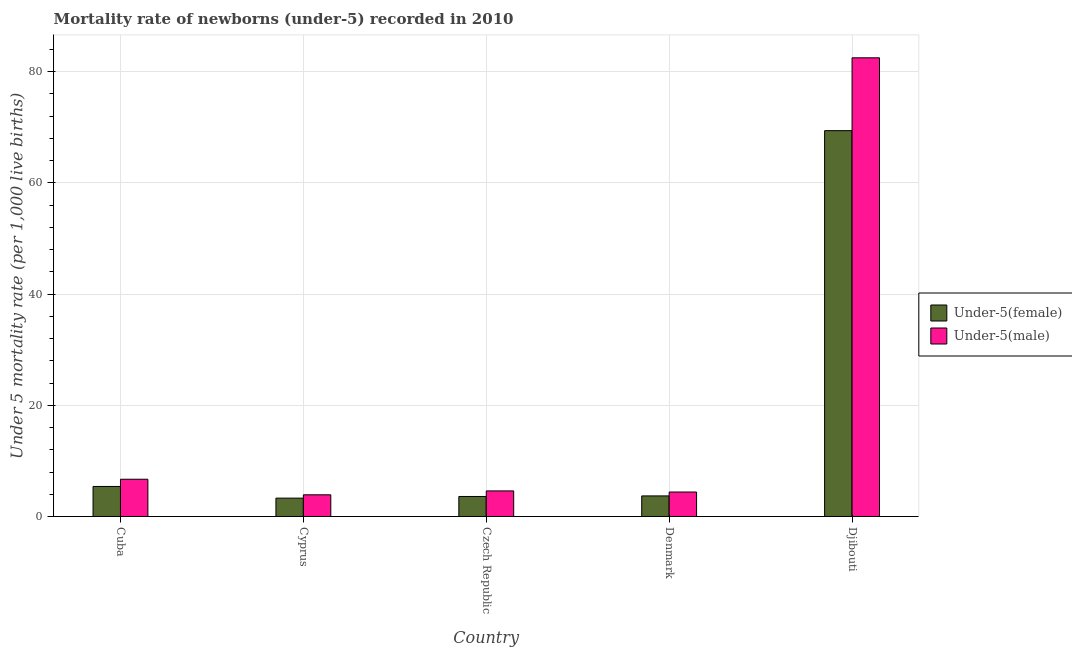What is the label of the 2nd group of bars from the left?
Offer a terse response. Cyprus. In how many cases, is the number of bars for a given country not equal to the number of legend labels?
Offer a very short reply. 0. Across all countries, what is the maximum under-5 female mortality rate?
Provide a short and direct response. 69.4. Across all countries, what is the minimum under-5 female mortality rate?
Ensure brevity in your answer.  3.3. In which country was the under-5 male mortality rate maximum?
Make the answer very short. Djibouti. In which country was the under-5 female mortality rate minimum?
Make the answer very short. Cyprus. What is the total under-5 female mortality rate in the graph?
Your answer should be compact. 85.4. What is the difference between the under-5 male mortality rate in Cyprus and that in Djibouti?
Offer a very short reply. -78.6. What is the difference between the under-5 male mortality rate in Cuba and the under-5 female mortality rate in Djibouti?
Keep it short and to the point. -62.7. What is the average under-5 female mortality rate per country?
Your answer should be very brief. 17.08. What is the difference between the under-5 female mortality rate and under-5 male mortality rate in Cyprus?
Your response must be concise. -0.6. In how many countries, is the under-5 female mortality rate greater than 36 ?
Your answer should be very brief. 1. What is the ratio of the under-5 female mortality rate in Czech Republic to that in Djibouti?
Your response must be concise. 0.05. Is the under-5 male mortality rate in Cyprus less than that in Denmark?
Keep it short and to the point. Yes. Is the difference between the under-5 female mortality rate in Cyprus and Czech Republic greater than the difference between the under-5 male mortality rate in Cyprus and Czech Republic?
Your answer should be compact. Yes. What is the difference between the highest and the second highest under-5 male mortality rate?
Provide a succinct answer. 75.8. What is the difference between the highest and the lowest under-5 male mortality rate?
Your answer should be compact. 78.6. In how many countries, is the under-5 female mortality rate greater than the average under-5 female mortality rate taken over all countries?
Your response must be concise. 1. Is the sum of the under-5 female mortality rate in Czech Republic and Denmark greater than the maximum under-5 male mortality rate across all countries?
Provide a short and direct response. No. What does the 2nd bar from the left in Denmark represents?
Your answer should be very brief. Under-5(male). What does the 2nd bar from the right in Cyprus represents?
Offer a terse response. Under-5(female). How many countries are there in the graph?
Provide a short and direct response. 5. Are the values on the major ticks of Y-axis written in scientific E-notation?
Make the answer very short. No. Does the graph contain any zero values?
Your answer should be very brief. No. Where does the legend appear in the graph?
Your answer should be very brief. Center right. How are the legend labels stacked?
Make the answer very short. Vertical. What is the title of the graph?
Your answer should be compact. Mortality rate of newborns (under-5) recorded in 2010. Does "Male labourers" appear as one of the legend labels in the graph?
Your answer should be very brief. No. What is the label or title of the X-axis?
Give a very brief answer. Country. What is the label or title of the Y-axis?
Your answer should be very brief. Under 5 mortality rate (per 1,0 live births). What is the Under 5 mortality rate (per 1,000 live births) of Under-5(male) in Cuba?
Keep it short and to the point. 6.7. What is the Under 5 mortality rate (per 1,000 live births) of Under-5(female) in Djibouti?
Offer a very short reply. 69.4. What is the Under 5 mortality rate (per 1,000 live births) in Under-5(male) in Djibouti?
Provide a succinct answer. 82.5. Across all countries, what is the maximum Under 5 mortality rate (per 1,000 live births) of Under-5(female)?
Your response must be concise. 69.4. Across all countries, what is the maximum Under 5 mortality rate (per 1,000 live births) of Under-5(male)?
Offer a very short reply. 82.5. Across all countries, what is the minimum Under 5 mortality rate (per 1,000 live births) in Under-5(male)?
Your answer should be compact. 3.9. What is the total Under 5 mortality rate (per 1,000 live births) of Under-5(female) in the graph?
Your answer should be compact. 85.4. What is the total Under 5 mortality rate (per 1,000 live births) of Under-5(male) in the graph?
Your answer should be compact. 102.1. What is the difference between the Under 5 mortality rate (per 1,000 live births) of Under-5(female) in Cuba and that in Czech Republic?
Provide a succinct answer. 1.8. What is the difference between the Under 5 mortality rate (per 1,000 live births) of Under-5(male) in Cuba and that in Czech Republic?
Ensure brevity in your answer.  2.1. What is the difference between the Under 5 mortality rate (per 1,000 live births) in Under-5(female) in Cuba and that in Denmark?
Provide a succinct answer. 1.7. What is the difference between the Under 5 mortality rate (per 1,000 live births) of Under-5(female) in Cuba and that in Djibouti?
Your response must be concise. -64. What is the difference between the Under 5 mortality rate (per 1,000 live births) in Under-5(male) in Cuba and that in Djibouti?
Give a very brief answer. -75.8. What is the difference between the Under 5 mortality rate (per 1,000 live births) of Under-5(female) in Cyprus and that in Czech Republic?
Provide a short and direct response. -0.3. What is the difference between the Under 5 mortality rate (per 1,000 live births) in Under-5(male) in Cyprus and that in Czech Republic?
Your response must be concise. -0.7. What is the difference between the Under 5 mortality rate (per 1,000 live births) of Under-5(male) in Cyprus and that in Denmark?
Your answer should be very brief. -0.5. What is the difference between the Under 5 mortality rate (per 1,000 live births) in Under-5(female) in Cyprus and that in Djibouti?
Provide a short and direct response. -66.1. What is the difference between the Under 5 mortality rate (per 1,000 live births) in Under-5(male) in Cyprus and that in Djibouti?
Ensure brevity in your answer.  -78.6. What is the difference between the Under 5 mortality rate (per 1,000 live births) in Under-5(female) in Czech Republic and that in Djibouti?
Provide a succinct answer. -65.8. What is the difference between the Under 5 mortality rate (per 1,000 live births) in Under-5(male) in Czech Republic and that in Djibouti?
Your response must be concise. -77.9. What is the difference between the Under 5 mortality rate (per 1,000 live births) in Under-5(female) in Denmark and that in Djibouti?
Give a very brief answer. -65.7. What is the difference between the Under 5 mortality rate (per 1,000 live births) in Under-5(male) in Denmark and that in Djibouti?
Provide a succinct answer. -78.1. What is the difference between the Under 5 mortality rate (per 1,000 live births) in Under-5(female) in Cuba and the Under 5 mortality rate (per 1,000 live births) in Under-5(male) in Cyprus?
Offer a terse response. 1.5. What is the difference between the Under 5 mortality rate (per 1,000 live births) of Under-5(female) in Cuba and the Under 5 mortality rate (per 1,000 live births) of Under-5(male) in Czech Republic?
Your answer should be compact. 0.8. What is the difference between the Under 5 mortality rate (per 1,000 live births) in Under-5(female) in Cuba and the Under 5 mortality rate (per 1,000 live births) in Under-5(male) in Denmark?
Keep it short and to the point. 1. What is the difference between the Under 5 mortality rate (per 1,000 live births) of Under-5(female) in Cuba and the Under 5 mortality rate (per 1,000 live births) of Under-5(male) in Djibouti?
Keep it short and to the point. -77.1. What is the difference between the Under 5 mortality rate (per 1,000 live births) of Under-5(female) in Cyprus and the Under 5 mortality rate (per 1,000 live births) of Under-5(male) in Czech Republic?
Offer a very short reply. -1.3. What is the difference between the Under 5 mortality rate (per 1,000 live births) in Under-5(female) in Cyprus and the Under 5 mortality rate (per 1,000 live births) in Under-5(male) in Djibouti?
Your answer should be compact. -79.2. What is the difference between the Under 5 mortality rate (per 1,000 live births) of Under-5(female) in Czech Republic and the Under 5 mortality rate (per 1,000 live births) of Under-5(male) in Denmark?
Offer a very short reply. -0.8. What is the difference between the Under 5 mortality rate (per 1,000 live births) in Under-5(female) in Czech Republic and the Under 5 mortality rate (per 1,000 live births) in Under-5(male) in Djibouti?
Provide a succinct answer. -78.9. What is the difference between the Under 5 mortality rate (per 1,000 live births) in Under-5(female) in Denmark and the Under 5 mortality rate (per 1,000 live births) in Under-5(male) in Djibouti?
Your answer should be compact. -78.8. What is the average Under 5 mortality rate (per 1,000 live births) of Under-5(female) per country?
Ensure brevity in your answer.  17.08. What is the average Under 5 mortality rate (per 1,000 live births) in Under-5(male) per country?
Your answer should be compact. 20.42. What is the difference between the Under 5 mortality rate (per 1,000 live births) in Under-5(female) and Under 5 mortality rate (per 1,000 live births) in Under-5(male) in Cuba?
Your answer should be very brief. -1.3. What is the difference between the Under 5 mortality rate (per 1,000 live births) of Under-5(female) and Under 5 mortality rate (per 1,000 live births) of Under-5(male) in Czech Republic?
Provide a short and direct response. -1. What is the ratio of the Under 5 mortality rate (per 1,000 live births) of Under-5(female) in Cuba to that in Cyprus?
Provide a short and direct response. 1.64. What is the ratio of the Under 5 mortality rate (per 1,000 live births) of Under-5(male) in Cuba to that in Cyprus?
Offer a terse response. 1.72. What is the ratio of the Under 5 mortality rate (per 1,000 live births) in Under-5(male) in Cuba to that in Czech Republic?
Your answer should be compact. 1.46. What is the ratio of the Under 5 mortality rate (per 1,000 live births) of Under-5(female) in Cuba to that in Denmark?
Your response must be concise. 1.46. What is the ratio of the Under 5 mortality rate (per 1,000 live births) in Under-5(male) in Cuba to that in Denmark?
Provide a succinct answer. 1.52. What is the ratio of the Under 5 mortality rate (per 1,000 live births) of Under-5(female) in Cuba to that in Djibouti?
Keep it short and to the point. 0.08. What is the ratio of the Under 5 mortality rate (per 1,000 live births) in Under-5(male) in Cuba to that in Djibouti?
Provide a succinct answer. 0.08. What is the ratio of the Under 5 mortality rate (per 1,000 live births) of Under-5(female) in Cyprus to that in Czech Republic?
Your response must be concise. 0.92. What is the ratio of the Under 5 mortality rate (per 1,000 live births) of Under-5(male) in Cyprus to that in Czech Republic?
Ensure brevity in your answer.  0.85. What is the ratio of the Under 5 mortality rate (per 1,000 live births) of Under-5(female) in Cyprus to that in Denmark?
Make the answer very short. 0.89. What is the ratio of the Under 5 mortality rate (per 1,000 live births) of Under-5(male) in Cyprus to that in Denmark?
Your answer should be compact. 0.89. What is the ratio of the Under 5 mortality rate (per 1,000 live births) in Under-5(female) in Cyprus to that in Djibouti?
Make the answer very short. 0.05. What is the ratio of the Under 5 mortality rate (per 1,000 live births) in Under-5(male) in Cyprus to that in Djibouti?
Ensure brevity in your answer.  0.05. What is the ratio of the Under 5 mortality rate (per 1,000 live births) in Under-5(female) in Czech Republic to that in Denmark?
Provide a short and direct response. 0.97. What is the ratio of the Under 5 mortality rate (per 1,000 live births) of Under-5(male) in Czech Republic to that in Denmark?
Keep it short and to the point. 1.05. What is the ratio of the Under 5 mortality rate (per 1,000 live births) of Under-5(female) in Czech Republic to that in Djibouti?
Your answer should be very brief. 0.05. What is the ratio of the Under 5 mortality rate (per 1,000 live births) in Under-5(male) in Czech Republic to that in Djibouti?
Provide a succinct answer. 0.06. What is the ratio of the Under 5 mortality rate (per 1,000 live births) in Under-5(female) in Denmark to that in Djibouti?
Offer a very short reply. 0.05. What is the ratio of the Under 5 mortality rate (per 1,000 live births) in Under-5(male) in Denmark to that in Djibouti?
Your answer should be very brief. 0.05. What is the difference between the highest and the second highest Under 5 mortality rate (per 1,000 live births) in Under-5(female)?
Make the answer very short. 64. What is the difference between the highest and the second highest Under 5 mortality rate (per 1,000 live births) in Under-5(male)?
Your answer should be very brief. 75.8. What is the difference between the highest and the lowest Under 5 mortality rate (per 1,000 live births) of Under-5(female)?
Your response must be concise. 66.1. What is the difference between the highest and the lowest Under 5 mortality rate (per 1,000 live births) in Under-5(male)?
Provide a succinct answer. 78.6. 